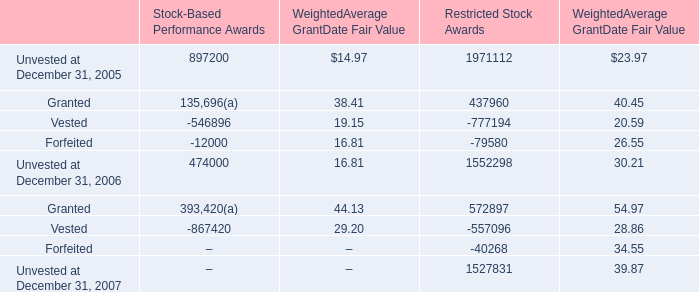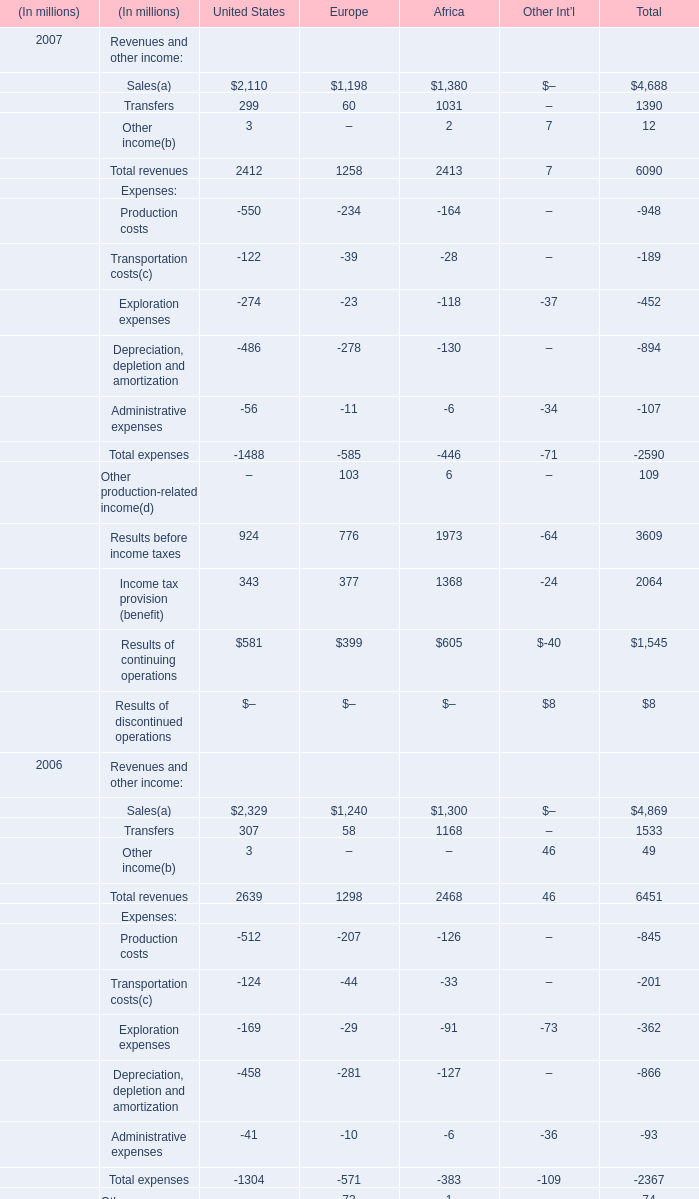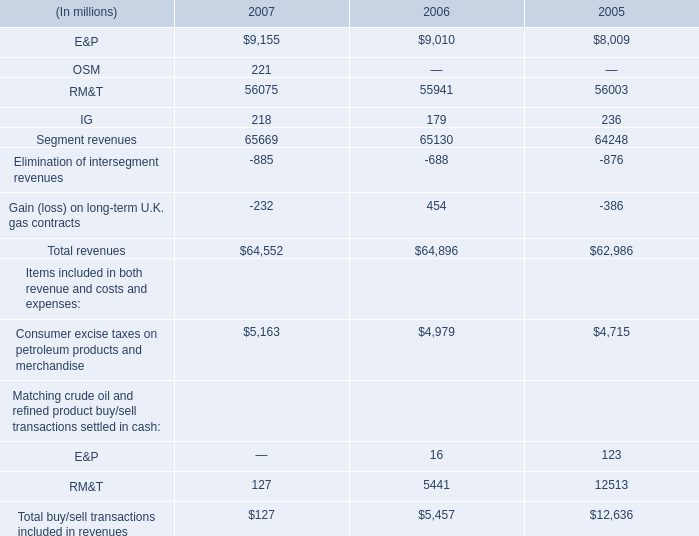what was the total vesting date fair value of restricted stock awards which vested during 2007 , 2006 and 2005 in $ million? 
Computations: ((29 + 32) + 13)
Answer: 74.0. 